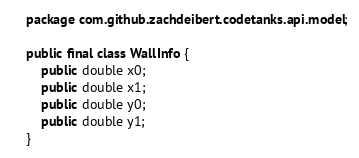Convert code to text. <code><loc_0><loc_0><loc_500><loc_500><_Java_>package com.github.zachdeibert.codetanks.api.model;

public final class WallInfo {
	public double x0;
	public double x1;
	public double y0;
	public double y1;
}
</code> 